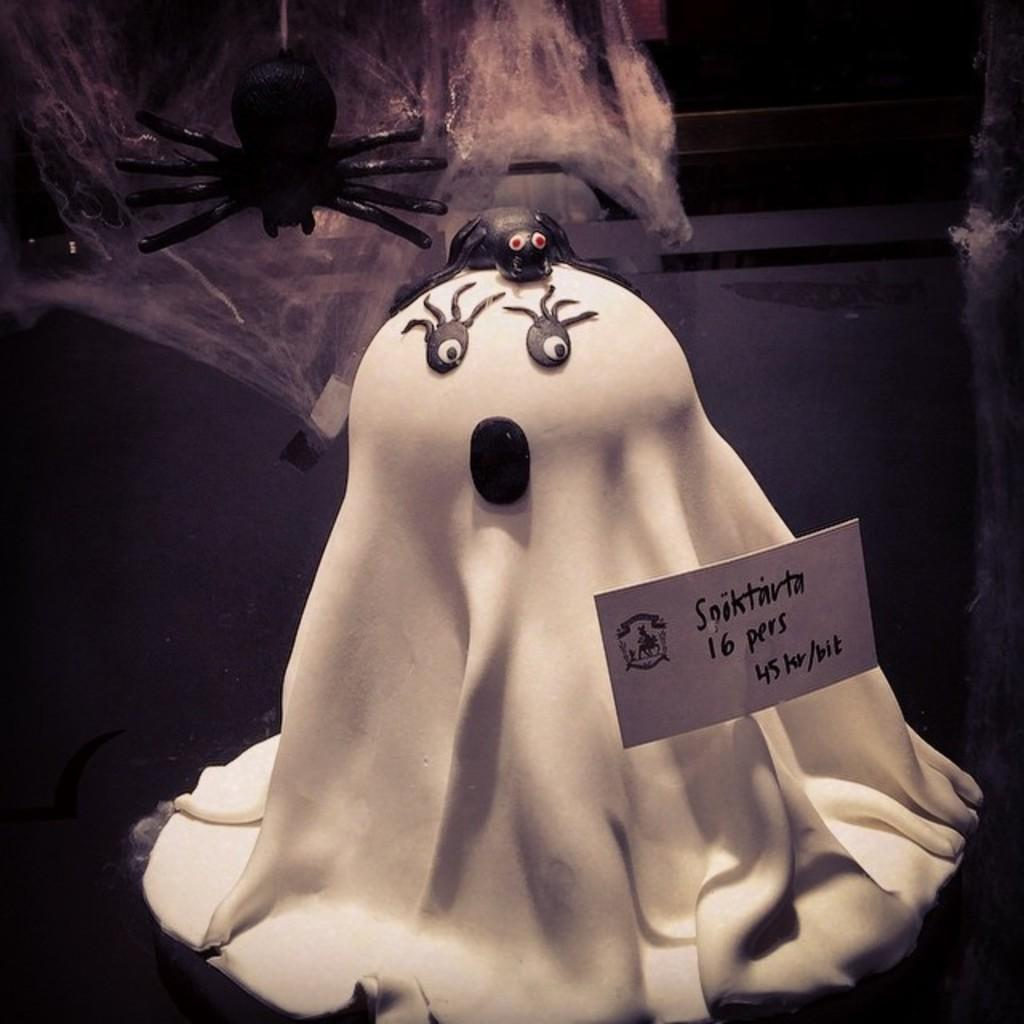What is the main subject of the image? There is a toy in the center of the image. What type of good-bye is the toy saying in the image? There is no indication in the image that the toy is saying good-bye or any other phrase. 